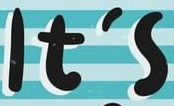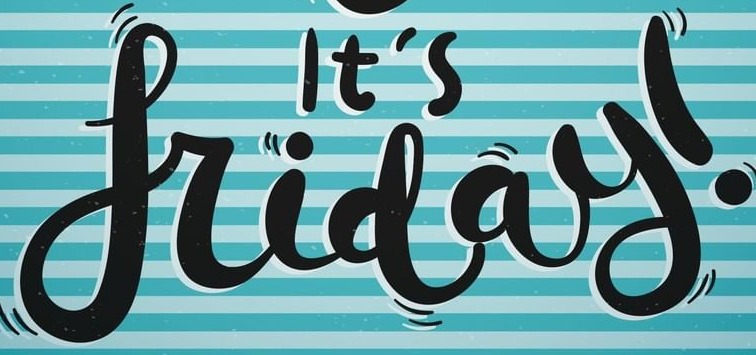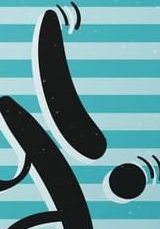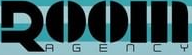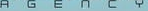What words can you see in these images in sequence, separated by a semicolon? It's; friday; !; ROOM; AGENCY 